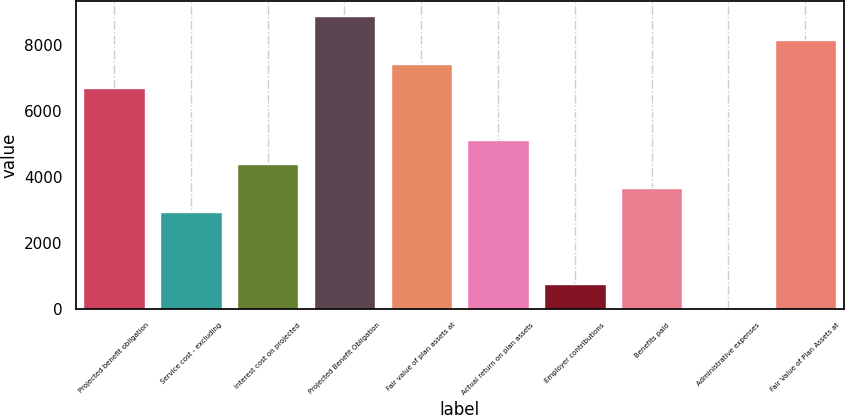<chart> <loc_0><loc_0><loc_500><loc_500><bar_chart><fcel>Projected benefit obligation<fcel>Service cost - excluding<fcel>Interest cost on projected<fcel>Projected Benefit Obligation<fcel>Fair value of plan assets at<fcel>Actual return on plan assets<fcel>Employer contributions<fcel>Benefits paid<fcel>Administrative expenses<fcel>Fair Value of Plan Assets at<nl><fcel>6695<fcel>2941.6<fcel>4399.4<fcel>8881.7<fcel>7423.9<fcel>5128.3<fcel>754.9<fcel>3670.5<fcel>26<fcel>8152.8<nl></chart> 